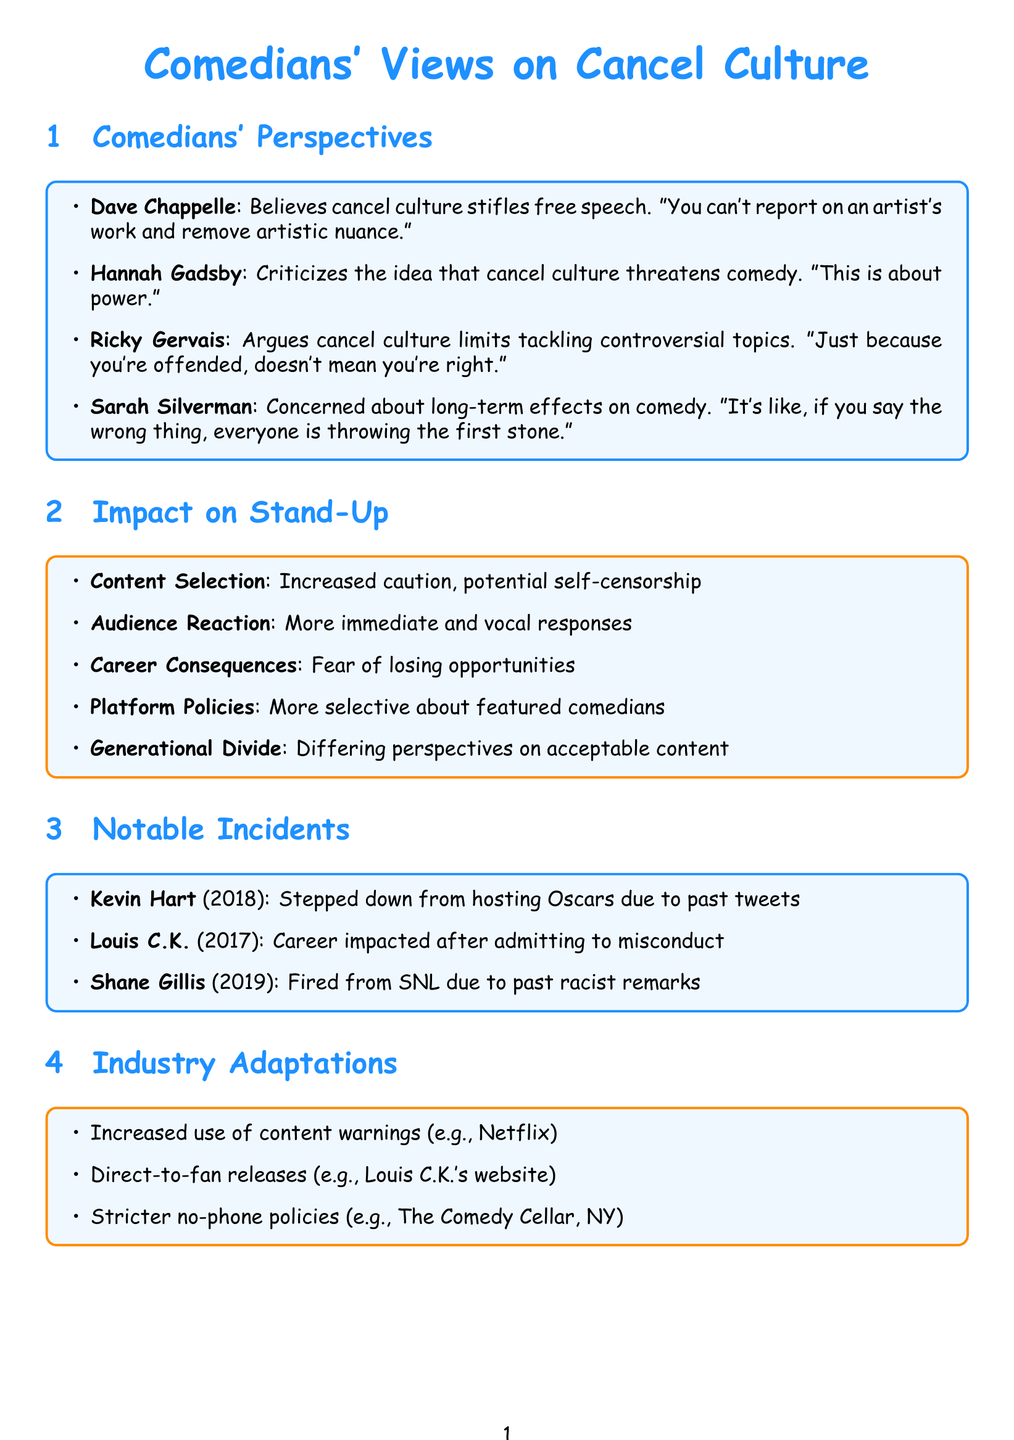What does Dave Chappelle believe about cancel culture? Dave Chappelle's view on cancel culture is that it stifles free speech in comedy.
Answer: Stifles free speech What year did Kevin Hart step down from hosting the Oscars? The incident involving Kevin Hart stepping down occurred in the year 2018.
Answer: 2018 What is one aspect affected by cancel culture on stand-up comedy? The document lists various aspects, one of which is "Content Selection."
Answer: Content Selection How does Hannah Gadsby perceive accountability in the comedy industry? Hannah Gadsby argues that accountability is necessary in the comedy industry.
Answer: Necessary What notable adaptation involves content warnings? The document mentions that there is an increased use of content warnings before comedy specials.
Answer: Increased use of content warnings What did Sarah Silverman express concern about? Sarah Silverman expressed concern about the long-term effects of cancel culture on comedy.
Answer: Long-term effects What incident significantly impacted Louis C.K.'s career? Louis C.K.'s career was significantly impacted after admitting to sexual misconduct allegations.
Answer: Sexual misconduct allegations How do audiences react to controversial material according to the document? The document states that there is an increased sensitivity in audiences leading to more immediate and vocal responses.
Answer: More immediate and vocal responses What is a generational divide mentioned in the document? The document refers to differing perspectives between established comedians and up-and-coming performers on acceptable content.
Answer: Differing perspectives 